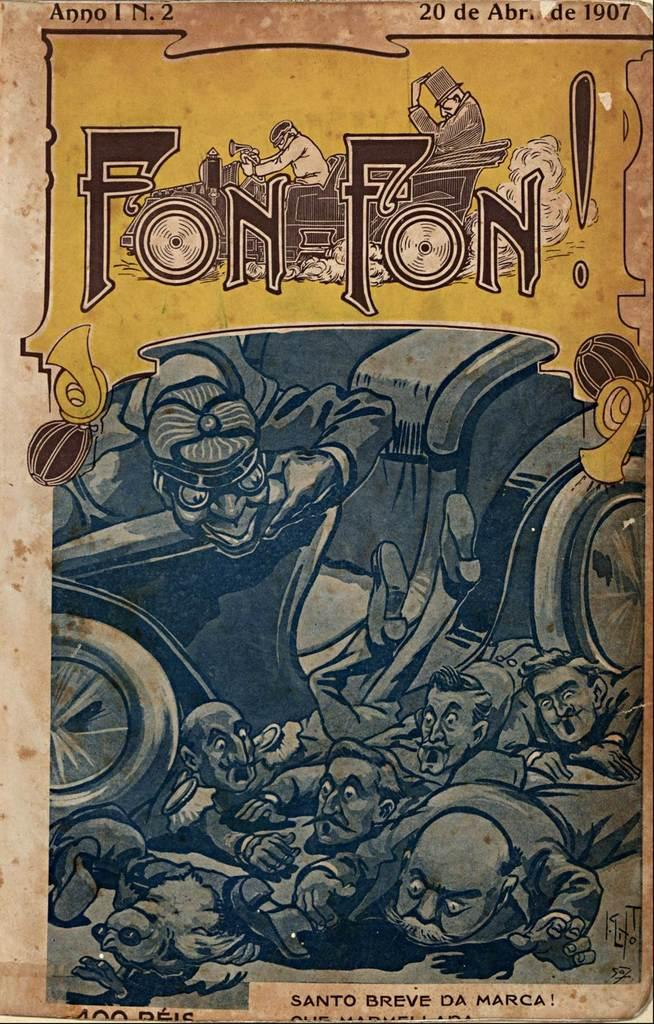What is present in the image? There is a poster in the image. What can be seen on the poster? The poster contains people and text. How many cent bears are depicted on the poster? There are no cent bears present on the poster; it contains people and text. 